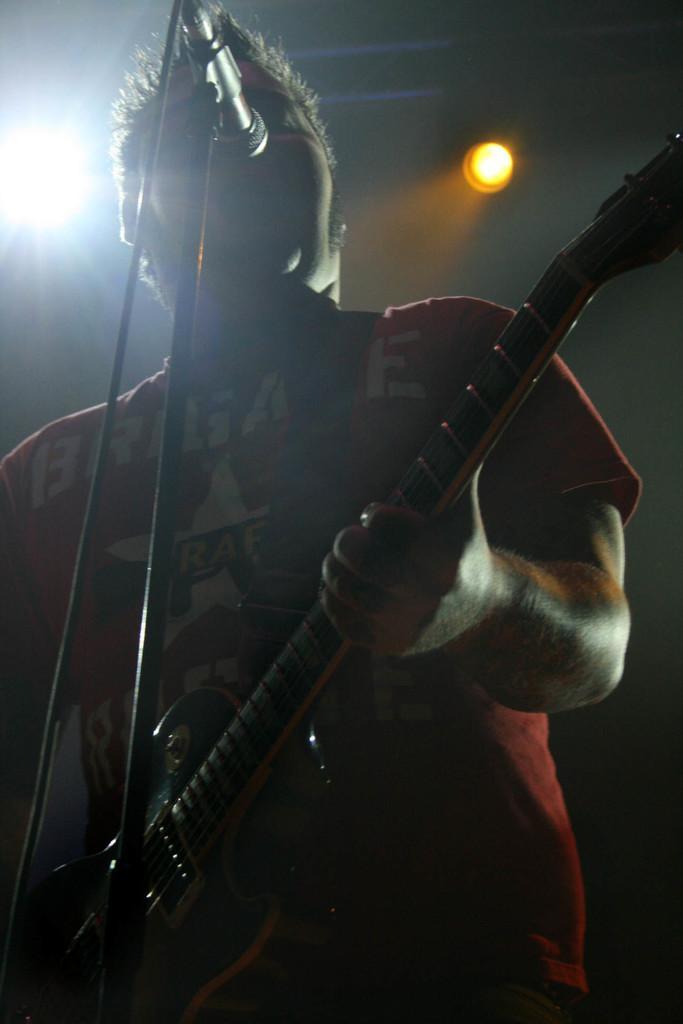Could you give a brief overview of what you see in this image? In the middle of the image a man is standing and playing guitar and there is a microphone. 